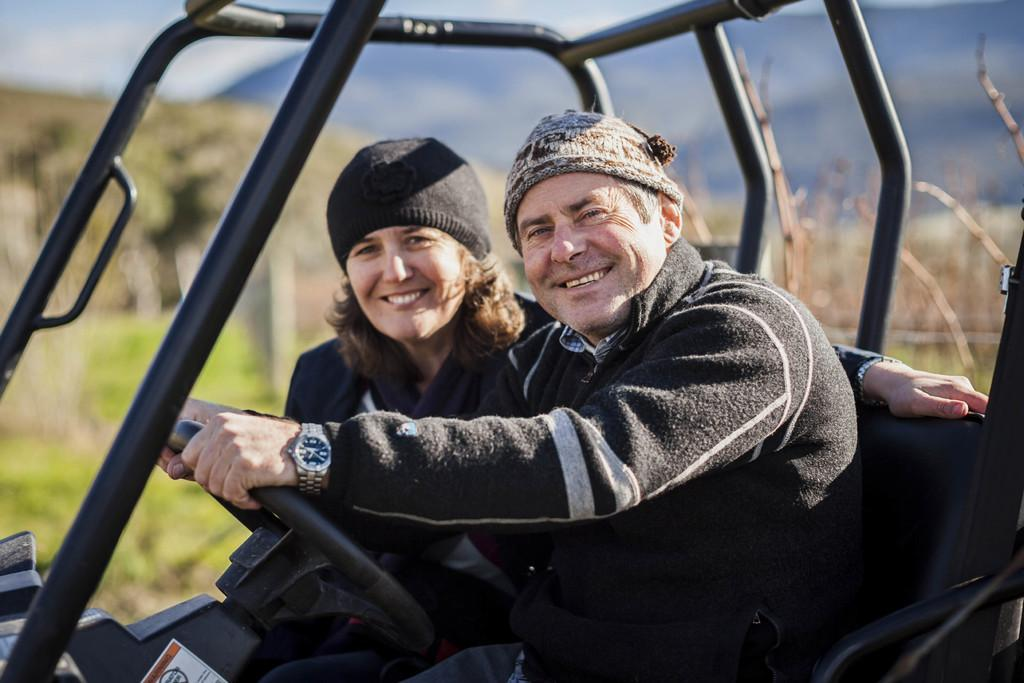What vehicle is present in the image? There is a jeep in the image. Who is inside the jeep? A man and a woman are sitting in the jeep. Can you describe the background of the image? The background of the image is blurred. What type of shop can be seen in the background of the image? There is no shop visible in the image; the background is blurred. What tool is the man using to fix the jeep in the image? There is no indication in the image that the man is using a wrench or any other tool to fix the jeep. 